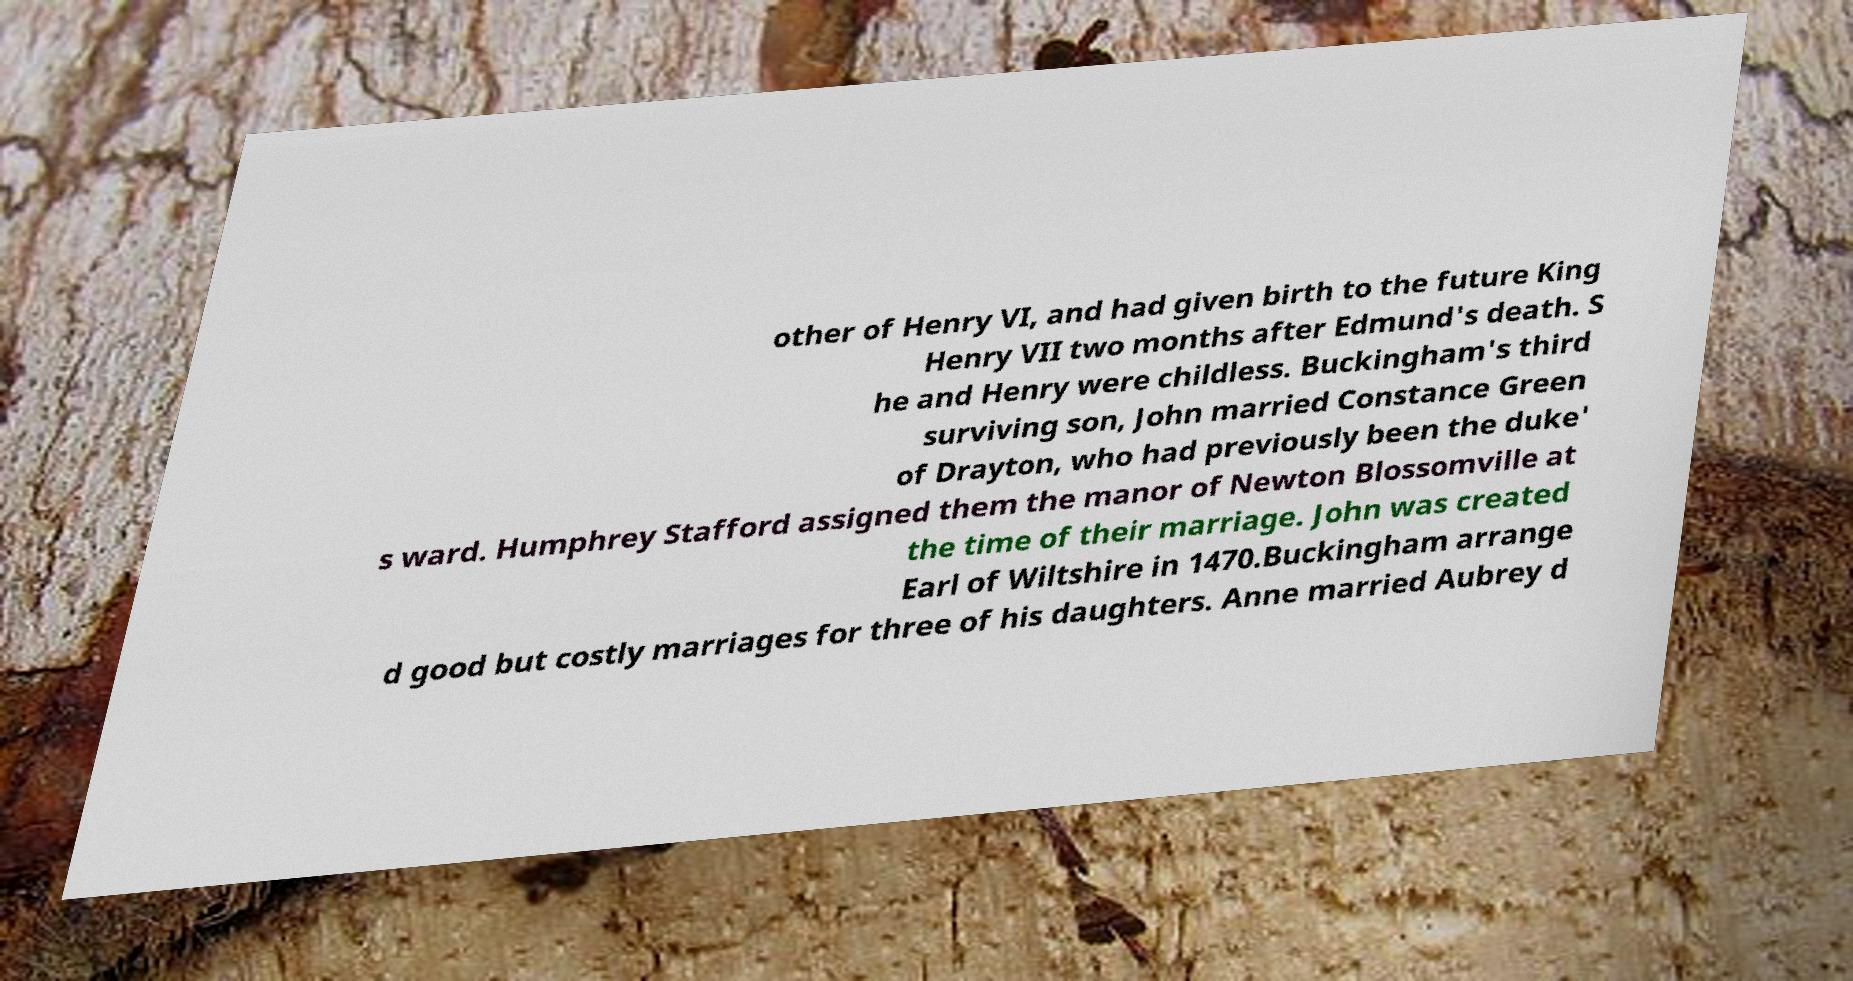For documentation purposes, I need the text within this image transcribed. Could you provide that? other of Henry VI, and had given birth to the future King Henry VII two months after Edmund's death. S he and Henry were childless. Buckingham's third surviving son, John married Constance Green of Drayton, who had previously been the duke' s ward. Humphrey Stafford assigned them the manor of Newton Blossomville at the time of their marriage. John was created Earl of Wiltshire in 1470.Buckingham arrange d good but costly marriages for three of his daughters. Anne married Aubrey d 